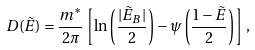<formula> <loc_0><loc_0><loc_500><loc_500>D ( \tilde { E } ) = \frac { m ^ { * } } { 2 \pi } \left [ \ln \left ( \frac { | \tilde { E } _ { B } | } { 2 } \right ) - \psi \left ( \frac { 1 - \tilde { E } } { 2 } \right ) \right ] \, ,</formula> 